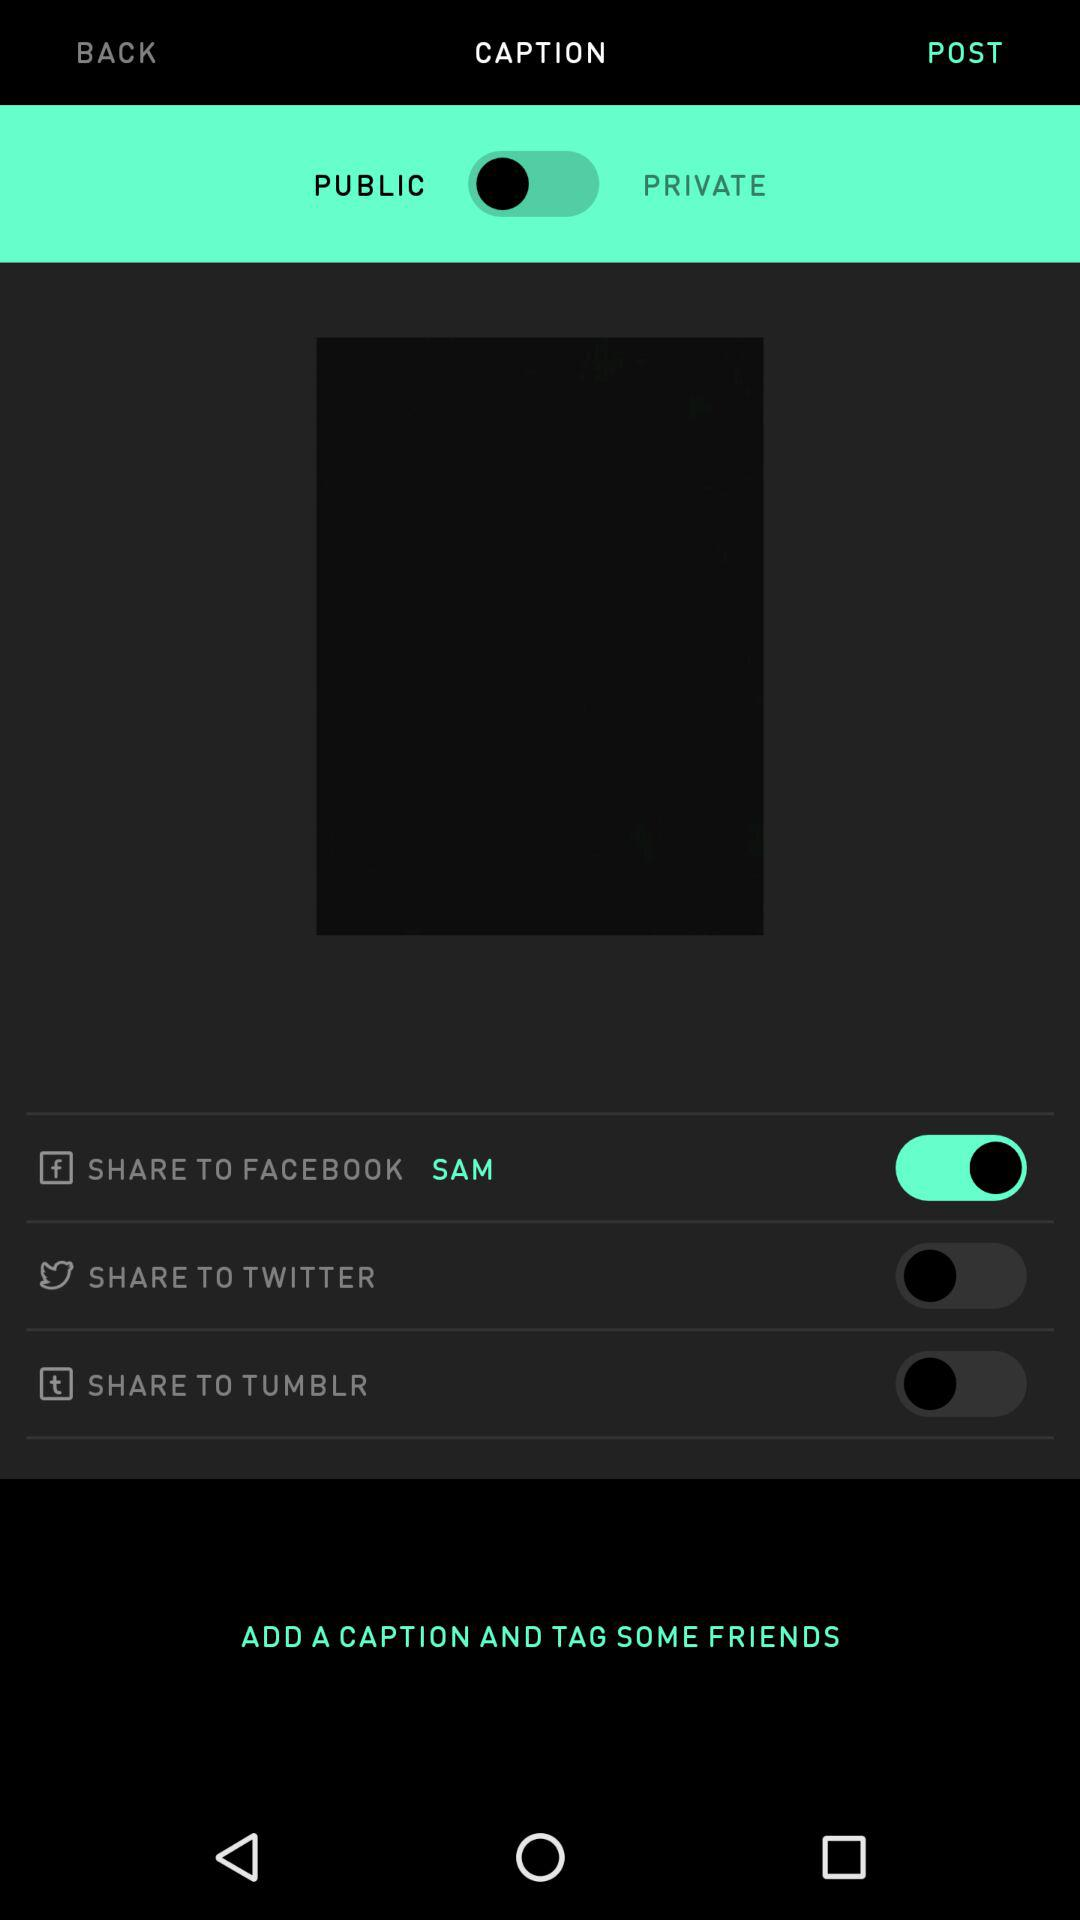What is the status of the "SHARE TO TWITTER" button? The status is "off". 